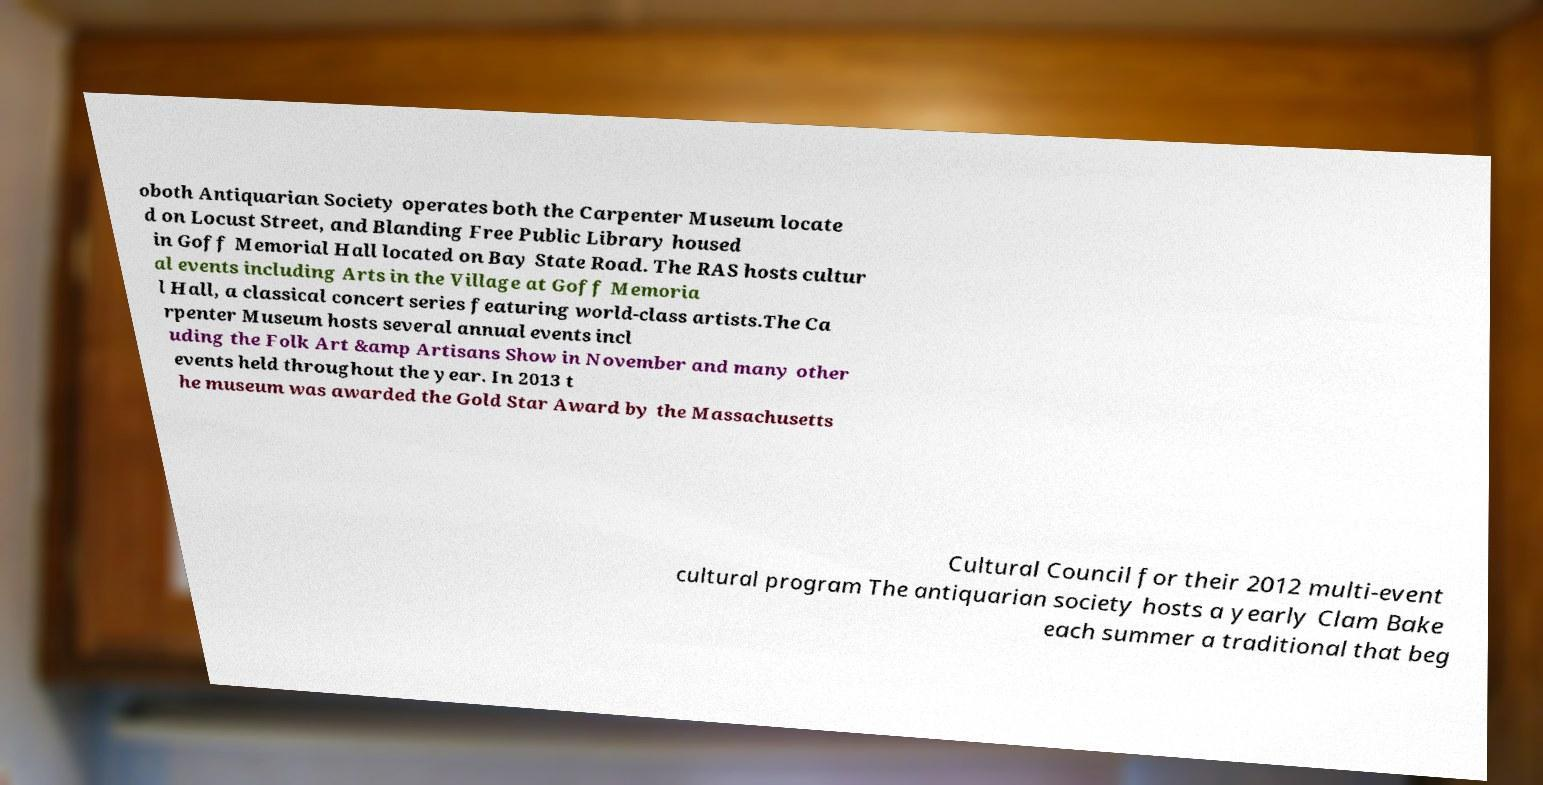Can you accurately transcribe the text from the provided image for me? oboth Antiquarian Society operates both the Carpenter Museum locate d on Locust Street, and Blanding Free Public Library housed in Goff Memorial Hall located on Bay State Road. The RAS hosts cultur al events including Arts in the Village at Goff Memoria l Hall, a classical concert series featuring world-class artists.The Ca rpenter Museum hosts several annual events incl uding the Folk Art &amp Artisans Show in November and many other events held throughout the year. In 2013 t he museum was awarded the Gold Star Award by the Massachusetts Cultural Council for their 2012 multi-event cultural program The antiquarian society hosts a yearly Clam Bake each summer a traditional that beg 